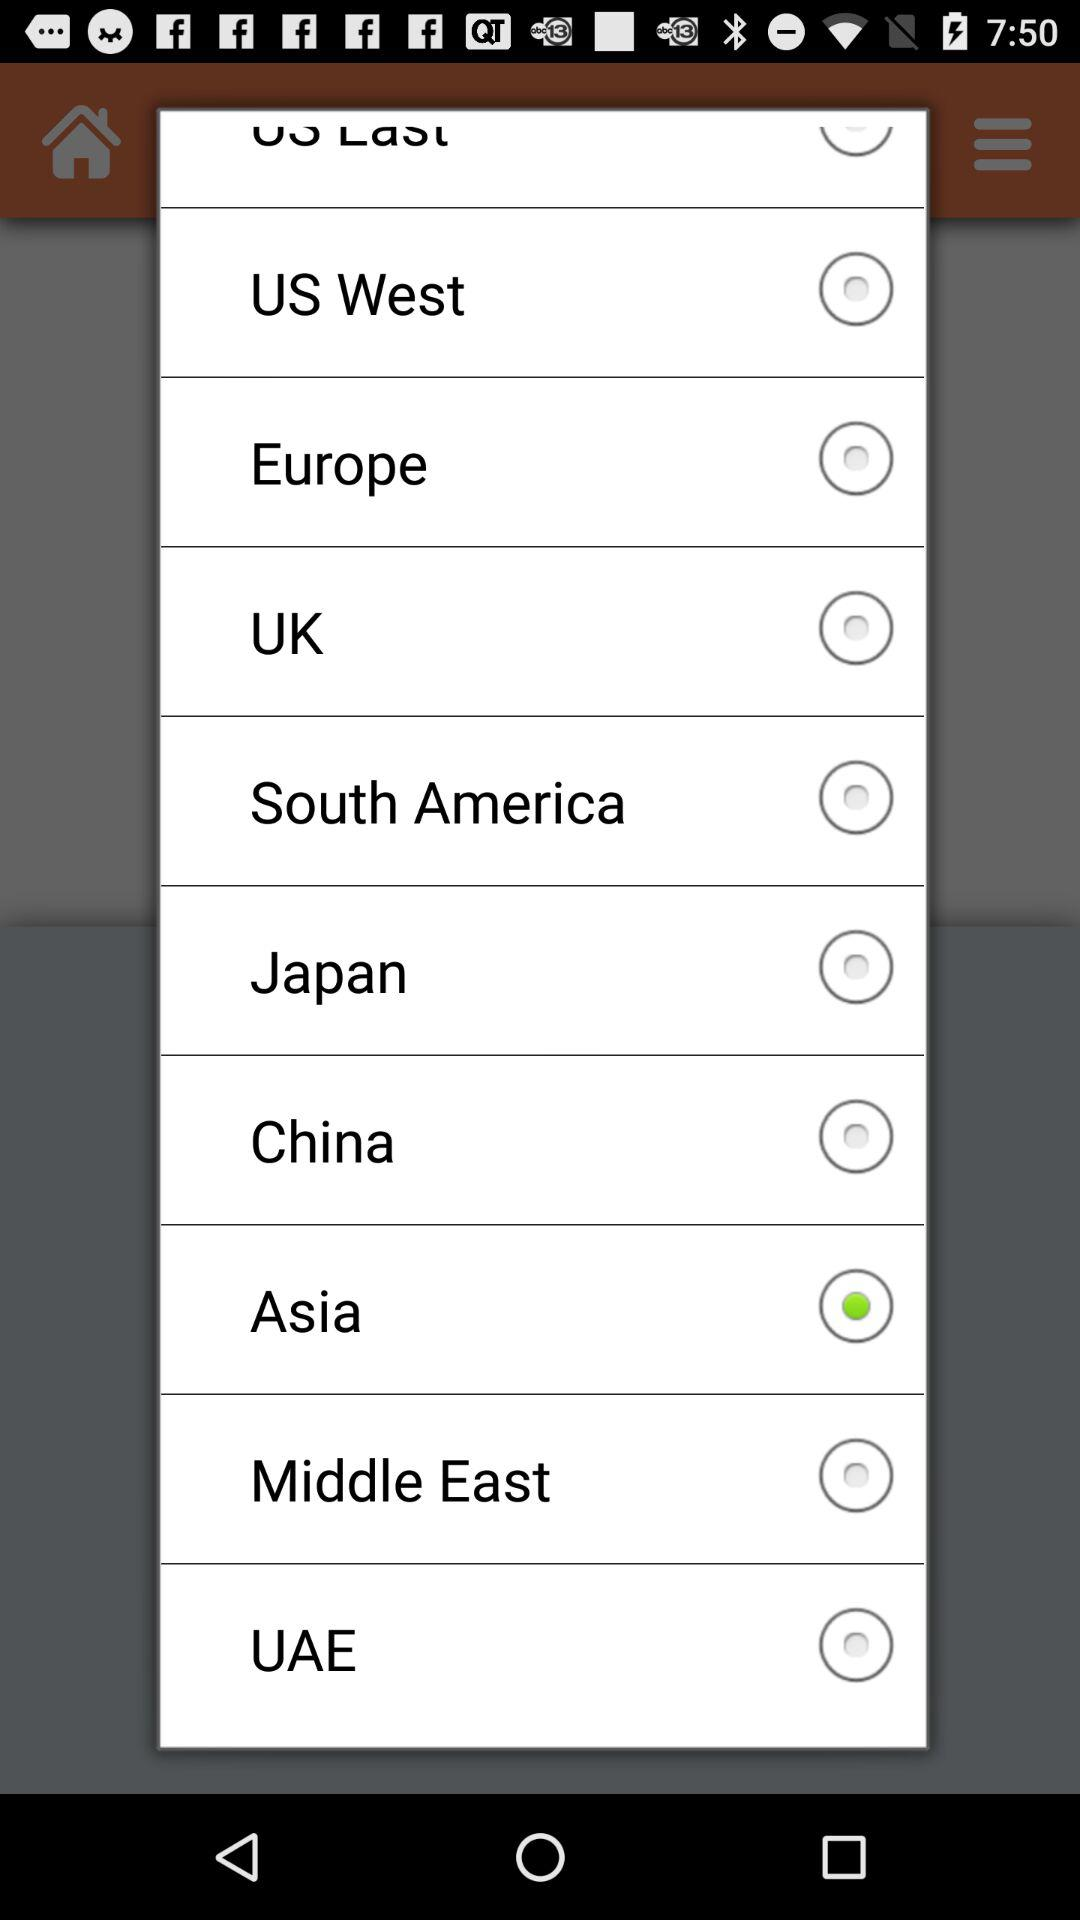What country was selected? The selected country was Asia. 